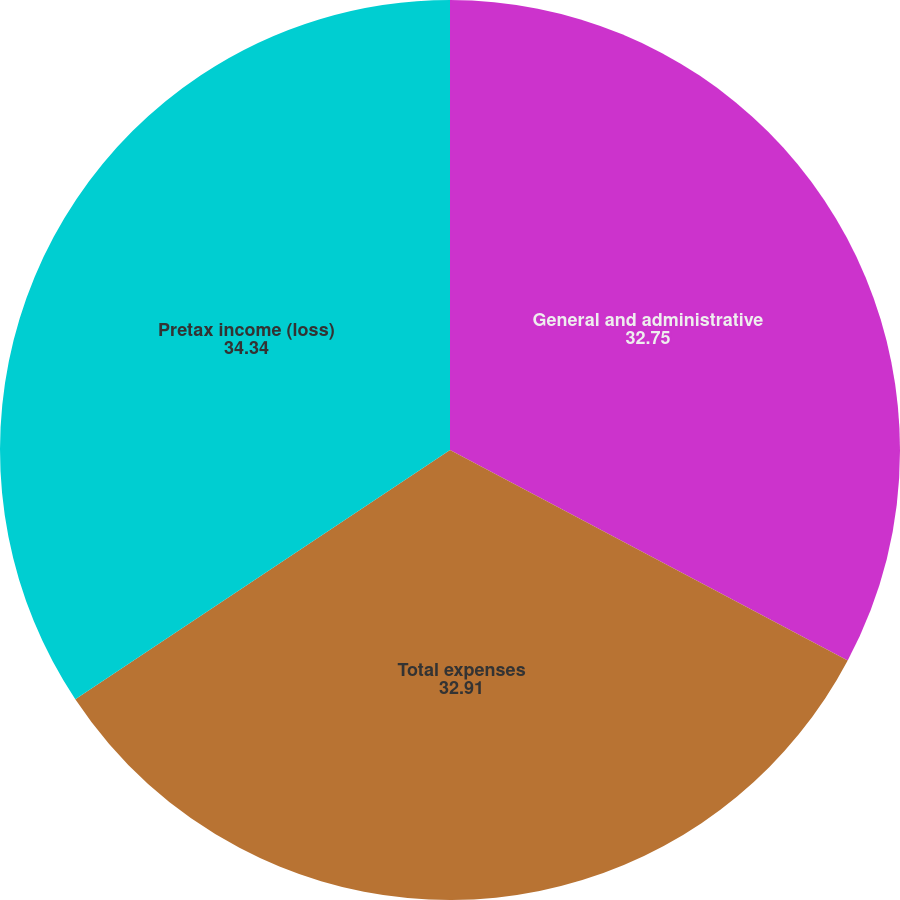Convert chart. <chart><loc_0><loc_0><loc_500><loc_500><pie_chart><fcel>General and administrative<fcel>Total expenses<fcel>Pretax income (loss)<nl><fcel>32.75%<fcel>32.91%<fcel>34.34%<nl></chart> 